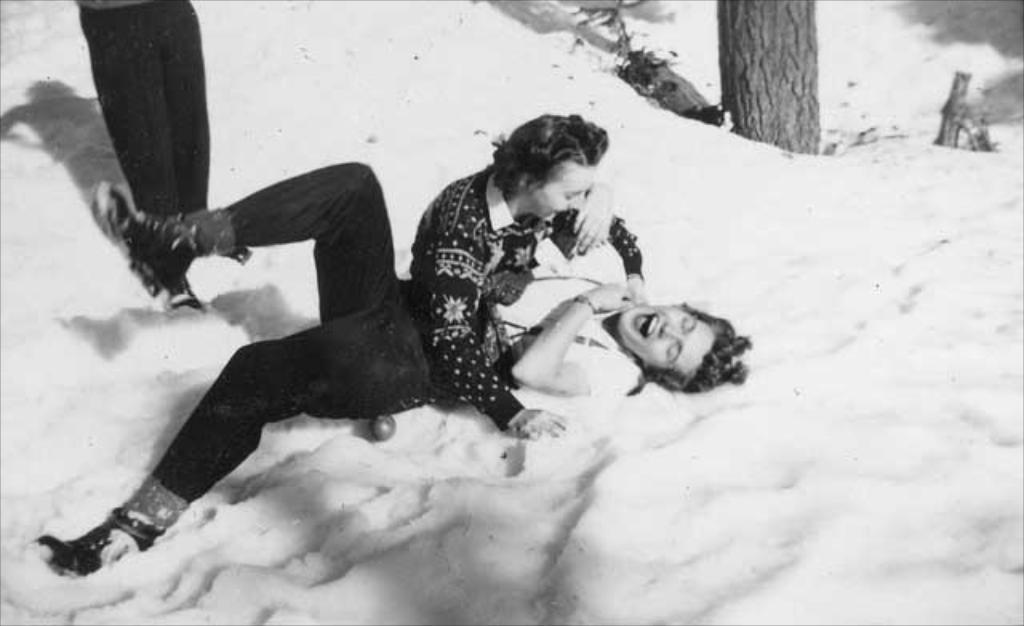What is the main subject of the image? The main subject of the image is people in the ice. What can be seen in the background of the image? There is a tree visible in the background of the image. What type of engine is powering the people in the ice? There is no engine present in the image; it features people in the ice. What punishment is being given to the people in the ice? There is no indication of punishment in the image; it simply shows people in the ice. 